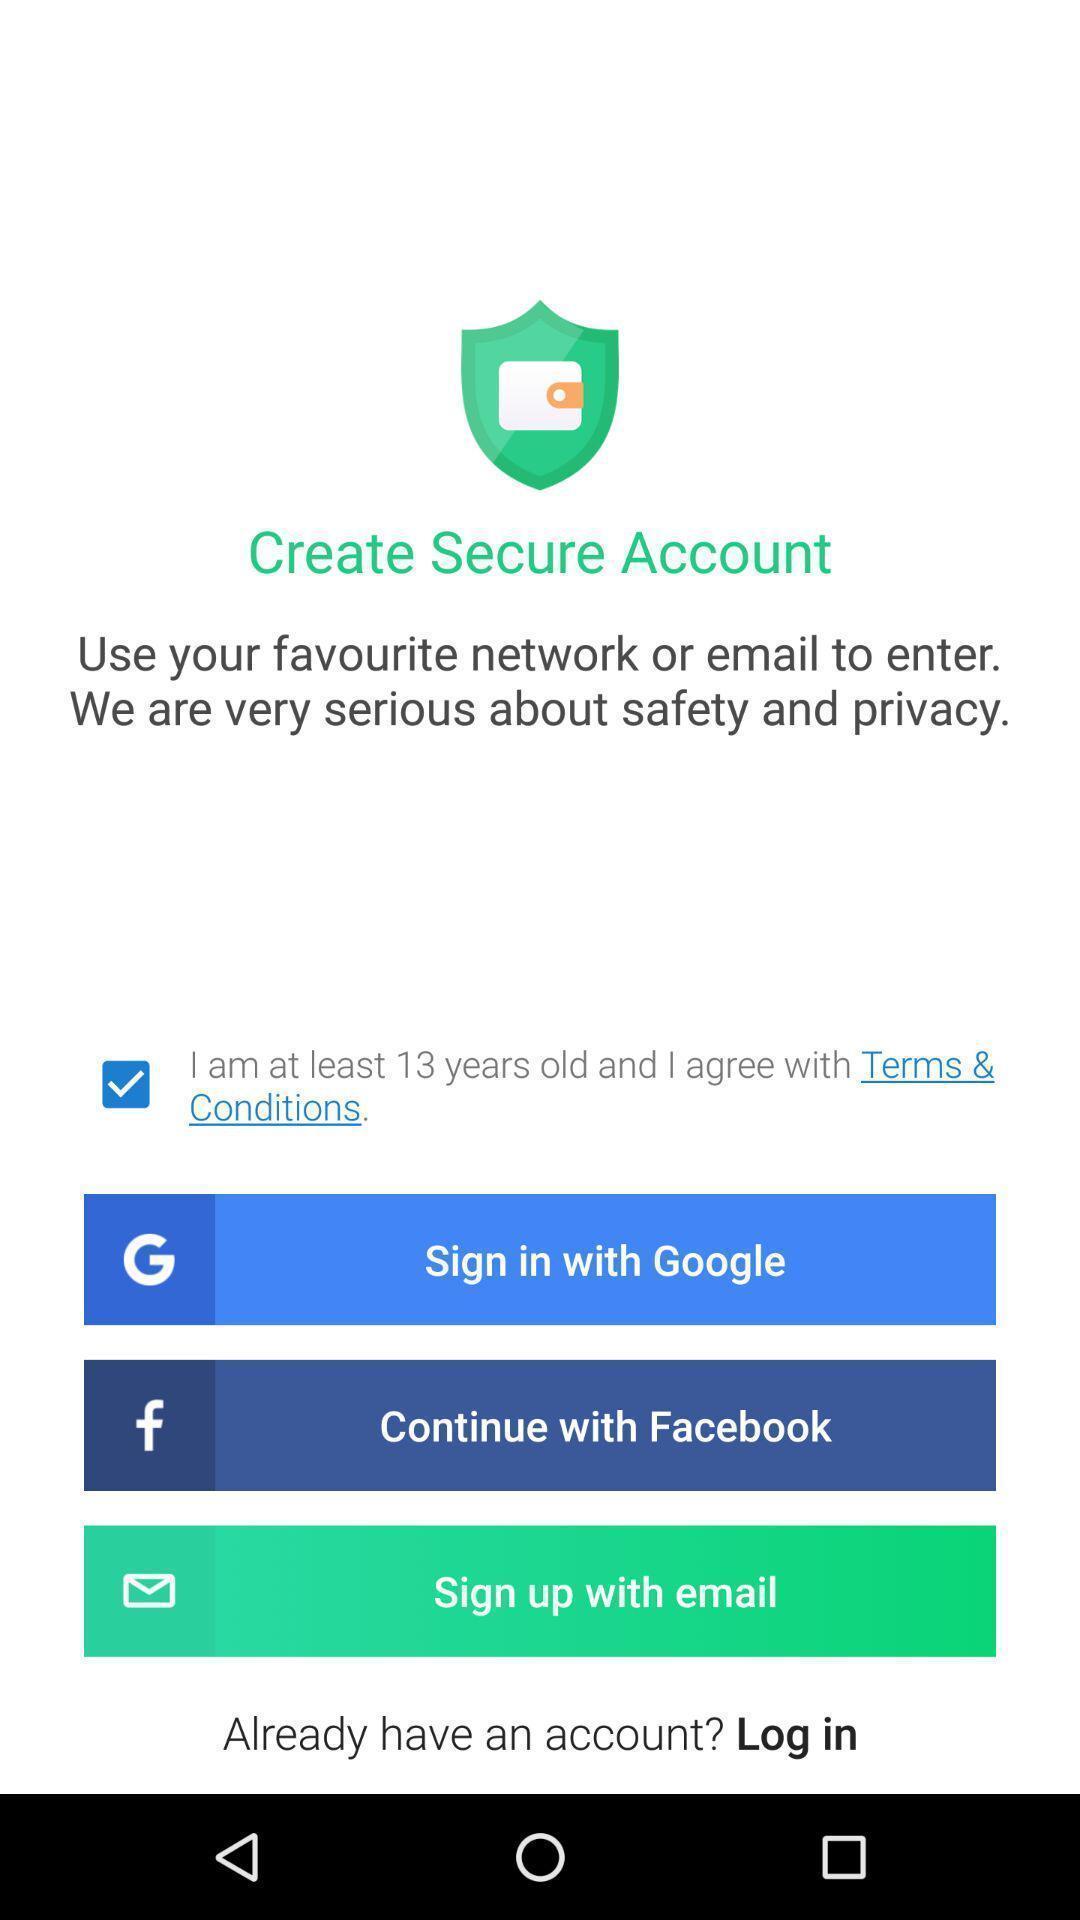Give me a summary of this screen capture. Sign in page with sign in options for creating account. 